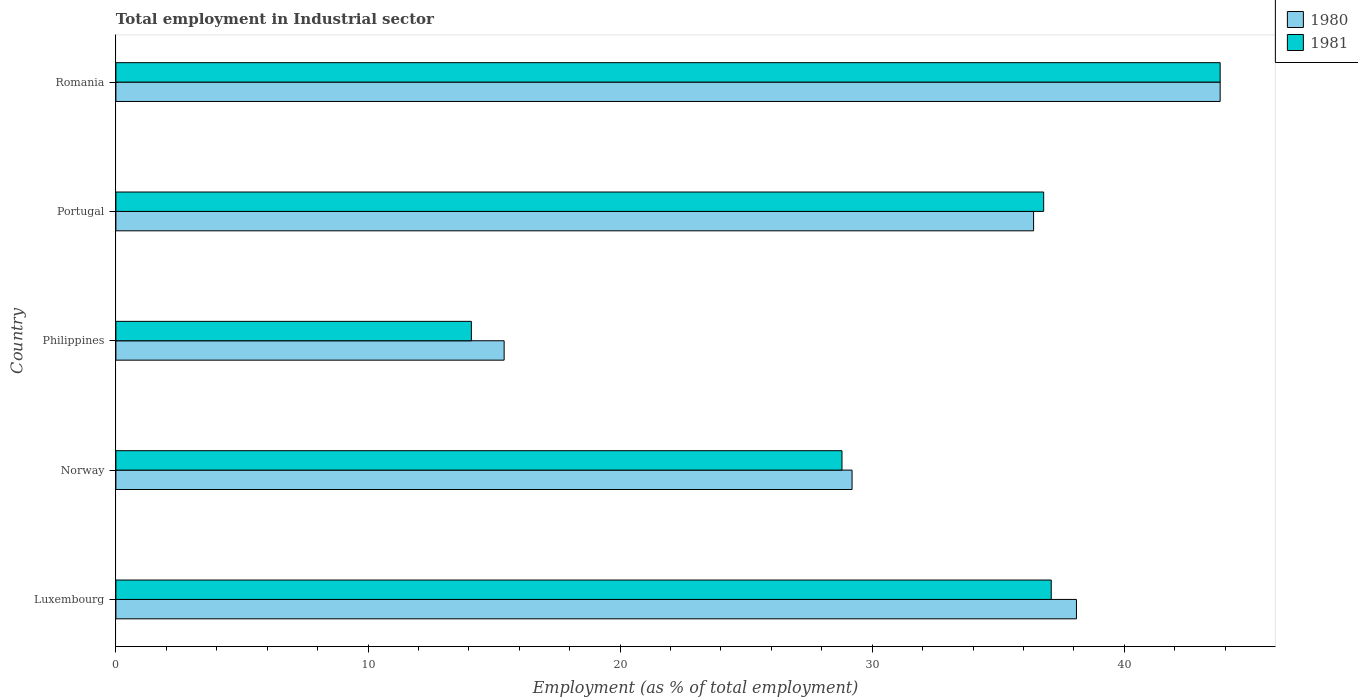Are the number of bars per tick equal to the number of legend labels?
Your answer should be very brief. Yes. Are the number of bars on each tick of the Y-axis equal?
Your answer should be compact. Yes. How many bars are there on the 2nd tick from the bottom?
Your response must be concise. 2. What is the label of the 5th group of bars from the top?
Provide a short and direct response. Luxembourg. In how many cases, is the number of bars for a given country not equal to the number of legend labels?
Make the answer very short. 0. What is the employment in industrial sector in 1981 in Portugal?
Give a very brief answer. 36.8. Across all countries, what is the maximum employment in industrial sector in 1980?
Give a very brief answer. 43.8. Across all countries, what is the minimum employment in industrial sector in 1980?
Your answer should be very brief. 15.4. In which country was the employment in industrial sector in 1981 maximum?
Your response must be concise. Romania. In which country was the employment in industrial sector in 1980 minimum?
Make the answer very short. Philippines. What is the total employment in industrial sector in 1980 in the graph?
Make the answer very short. 162.9. What is the difference between the employment in industrial sector in 1980 in Philippines and that in Romania?
Offer a terse response. -28.4. What is the difference between the employment in industrial sector in 1981 in Luxembourg and the employment in industrial sector in 1980 in Philippines?
Provide a succinct answer. 21.7. What is the average employment in industrial sector in 1980 per country?
Your response must be concise. 32.58. What is the difference between the employment in industrial sector in 1981 and employment in industrial sector in 1980 in Norway?
Offer a terse response. -0.4. In how many countries, is the employment in industrial sector in 1981 greater than 8 %?
Your response must be concise. 5. What is the ratio of the employment in industrial sector in 1981 in Norway to that in Portugal?
Make the answer very short. 0.78. Is the employment in industrial sector in 1980 in Portugal less than that in Romania?
Your answer should be compact. Yes. Is the difference between the employment in industrial sector in 1981 in Portugal and Romania greater than the difference between the employment in industrial sector in 1980 in Portugal and Romania?
Give a very brief answer. Yes. What is the difference between the highest and the second highest employment in industrial sector in 1980?
Your answer should be compact. 5.7. What is the difference between the highest and the lowest employment in industrial sector in 1981?
Keep it short and to the point. 29.7. In how many countries, is the employment in industrial sector in 1980 greater than the average employment in industrial sector in 1980 taken over all countries?
Make the answer very short. 3. What does the 2nd bar from the top in Norway represents?
Your answer should be compact. 1980. How many bars are there?
Offer a terse response. 10. How many countries are there in the graph?
Offer a very short reply. 5. Are the values on the major ticks of X-axis written in scientific E-notation?
Your answer should be very brief. No. Does the graph contain any zero values?
Ensure brevity in your answer.  No. How many legend labels are there?
Offer a terse response. 2. How are the legend labels stacked?
Give a very brief answer. Vertical. What is the title of the graph?
Your answer should be compact. Total employment in Industrial sector. What is the label or title of the X-axis?
Your response must be concise. Employment (as % of total employment). What is the Employment (as % of total employment) of 1980 in Luxembourg?
Ensure brevity in your answer.  38.1. What is the Employment (as % of total employment) of 1981 in Luxembourg?
Your response must be concise. 37.1. What is the Employment (as % of total employment) in 1980 in Norway?
Provide a short and direct response. 29.2. What is the Employment (as % of total employment) in 1981 in Norway?
Provide a succinct answer. 28.8. What is the Employment (as % of total employment) in 1980 in Philippines?
Offer a very short reply. 15.4. What is the Employment (as % of total employment) in 1981 in Philippines?
Offer a terse response. 14.1. What is the Employment (as % of total employment) in 1980 in Portugal?
Provide a short and direct response. 36.4. What is the Employment (as % of total employment) of 1981 in Portugal?
Your answer should be very brief. 36.8. What is the Employment (as % of total employment) in 1980 in Romania?
Make the answer very short. 43.8. What is the Employment (as % of total employment) in 1981 in Romania?
Offer a terse response. 43.8. Across all countries, what is the maximum Employment (as % of total employment) of 1980?
Offer a very short reply. 43.8. Across all countries, what is the maximum Employment (as % of total employment) in 1981?
Keep it short and to the point. 43.8. Across all countries, what is the minimum Employment (as % of total employment) in 1980?
Ensure brevity in your answer.  15.4. Across all countries, what is the minimum Employment (as % of total employment) in 1981?
Keep it short and to the point. 14.1. What is the total Employment (as % of total employment) of 1980 in the graph?
Your response must be concise. 162.9. What is the total Employment (as % of total employment) of 1981 in the graph?
Make the answer very short. 160.6. What is the difference between the Employment (as % of total employment) in 1980 in Luxembourg and that in Philippines?
Offer a very short reply. 22.7. What is the difference between the Employment (as % of total employment) in 1980 in Luxembourg and that in Romania?
Your answer should be very brief. -5.7. What is the difference between the Employment (as % of total employment) of 1981 in Norway and that in Philippines?
Your answer should be compact. 14.7. What is the difference between the Employment (as % of total employment) of 1980 in Norway and that in Portugal?
Make the answer very short. -7.2. What is the difference between the Employment (as % of total employment) of 1980 in Norway and that in Romania?
Provide a short and direct response. -14.6. What is the difference between the Employment (as % of total employment) in 1981 in Norway and that in Romania?
Make the answer very short. -15. What is the difference between the Employment (as % of total employment) of 1981 in Philippines and that in Portugal?
Offer a terse response. -22.7. What is the difference between the Employment (as % of total employment) of 1980 in Philippines and that in Romania?
Make the answer very short. -28.4. What is the difference between the Employment (as % of total employment) in 1981 in Philippines and that in Romania?
Your answer should be very brief. -29.7. What is the difference between the Employment (as % of total employment) in 1980 in Portugal and that in Romania?
Ensure brevity in your answer.  -7.4. What is the difference between the Employment (as % of total employment) in 1981 in Portugal and that in Romania?
Give a very brief answer. -7. What is the difference between the Employment (as % of total employment) in 1980 in Luxembourg and the Employment (as % of total employment) in 1981 in Philippines?
Your response must be concise. 24. What is the difference between the Employment (as % of total employment) in 1980 in Luxembourg and the Employment (as % of total employment) in 1981 in Portugal?
Your response must be concise. 1.3. What is the difference between the Employment (as % of total employment) of 1980 in Norway and the Employment (as % of total employment) of 1981 in Philippines?
Give a very brief answer. 15.1. What is the difference between the Employment (as % of total employment) in 1980 in Norway and the Employment (as % of total employment) in 1981 in Romania?
Your answer should be compact. -14.6. What is the difference between the Employment (as % of total employment) in 1980 in Philippines and the Employment (as % of total employment) in 1981 in Portugal?
Make the answer very short. -21.4. What is the difference between the Employment (as % of total employment) in 1980 in Philippines and the Employment (as % of total employment) in 1981 in Romania?
Offer a terse response. -28.4. What is the difference between the Employment (as % of total employment) of 1980 in Portugal and the Employment (as % of total employment) of 1981 in Romania?
Ensure brevity in your answer.  -7.4. What is the average Employment (as % of total employment) in 1980 per country?
Provide a succinct answer. 32.58. What is the average Employment (as % of total employment) of 1981 per country?
Provide a short and direct response. 32.12. What is the difference between the Employment (as % of total employment) of 1980 and Employment (as % of total employment) of 1981 in Norway?
Offer a terse response. 0.4. What is the ratio of the Employment (as % of total employment) in 1980 in Luxembourg to that in Norway?
Give a very brief answer. 1.3. What is the ratio of the Employment (as % of total employment) of 1981 in Luxembourg to that in Norway?
Provide a succinct answer. 1.29. What is the ratio of the Employment (as % of total employment) in 1980 in Luxembourg to that in Philippines?
Provide a succinct answer. 2.47. What is the ratio of the Employment (as % of total employment) in 1981 in Luxembourg to that in Philippines?
Offer a terse response. 2.63. What is the ratio of the Employment (as % of total employment) in 1980 in Luxembourg to that in Portugal?
Give a very brief answer. 1.05. What is the ratio of the Employment (as % of total employment) of 1981 in Luxembourg to that in Portugal?
Ensure brevity in your answer.  1.01. What is the ratio of the Employment (as % of total employment) of 1980 in Luxembourg to that in Romania?
Your answer should be very brief. 0.87. What is the ratio of the Employment (as % of total employment) in 1981 in Luxembourg to that in Romania?
Provide a short and direct response. 0.85. What is the ratio of the Employment (as % of total employment) of 1980 in Norway to that in Philippines?
Keep it short and to the point. 1.9. What is the ratio of the Employment (as % of total employment) in 1981 in Norway to that in Philippines?
Your answer should be compact. 2.04. What is the ratio of the Employment (as % of total employment) in 1980 in Norway to that in Portugal?
Ensure brevity in your answer.  0.8. What is the ratio of the Employment (as % of total employment) in 1981 in Norway to that in Portugal?
Make the answer very short. 0.78. What is the ratio of the Employment (as % of total employment) in 1981 in Norway to that in Romania?
Give a very brief answer. 0.66. What is the ratio of the Employment (as % of total employment) in 1980 in Philippines to that in Portugal?
Your response must be concise. 0.42. What is the ratio of the Employment (as % of total employment) in 1981 in Philippines to that in Portugal?
Keep it short and to the point. 0.38. What is the ratio of the Employment (as % of total employment) of 1980 in Philippines to that in Romania?
Provide a short and direct response. 0.35. What is the ratio of the Employment (as % of total employment) of 1981 in Philippines to that in Romania?
Your answer should be very brief. 0.32. What is the ratio of the Employment (as % of total employment) of 1980 in Portugal to that in Romania?
Your answer should be compact. 0.83. What is the ratio of the Employment (as % of total employment) in 1981 in Portugal to that in Romania?
Ensure brevity in your answer.  0.84. What is the difference between the highest and the second highest Employment (as % of total employment) in 1981?
Keep it short and to the point. 6.7. What is the difference between the highest and the lowest Employment (as % of total employment) of 1980?
Keep it short and to the point. 28.4. What is the difference between the highest and the lowest Employment (as % of total employment) in 1981?
Offer a very short reply. 29.7. 